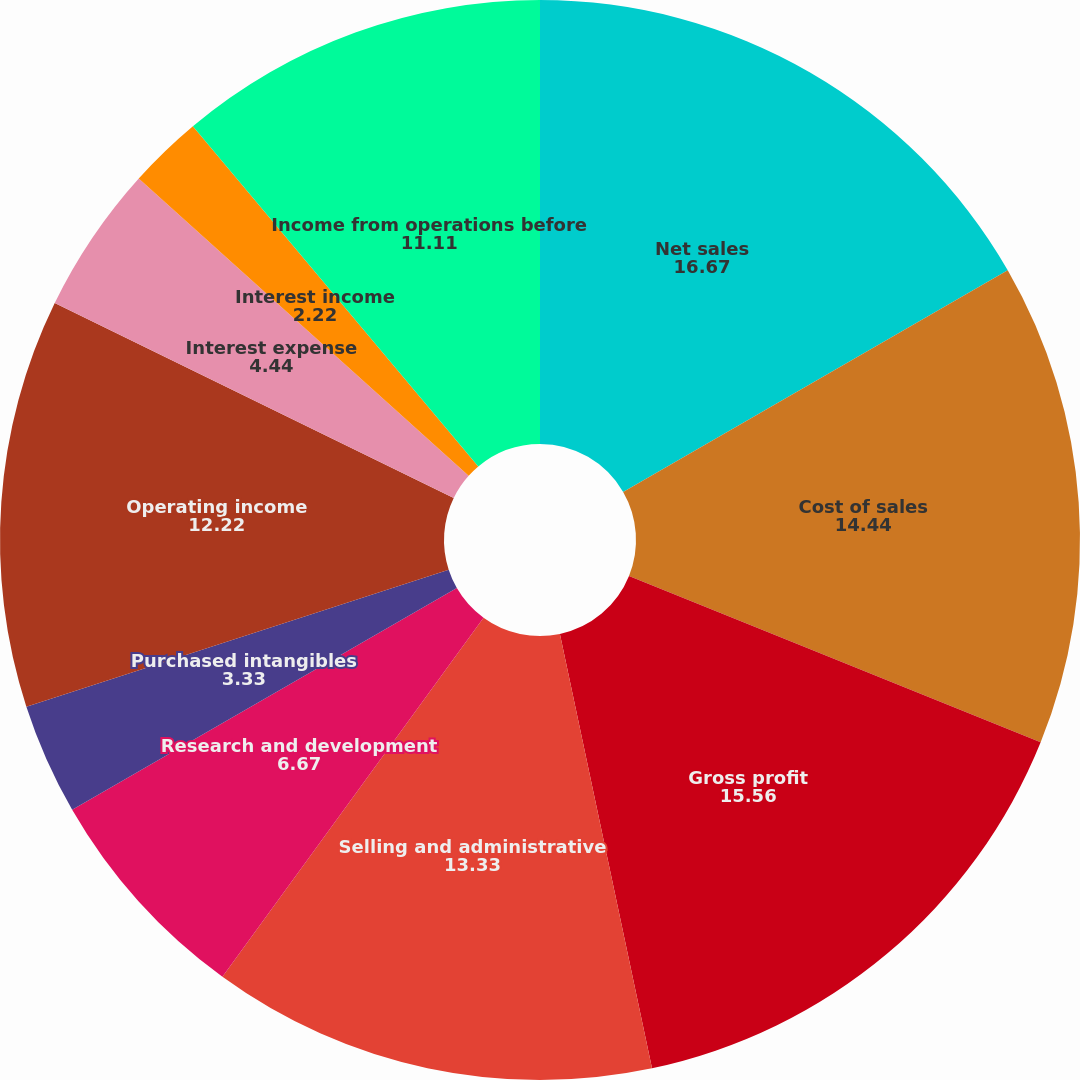<chart> <loc_0><loc_0><loc_500><loc_500><pie_chart><fcel>Net sales<fcel>Cost of sales<fcel>Gross profit<fcel>Selling and administrative<fcel>Research and development<fcel>Purchased intangibles<fcel>Operating income<fcel>Interest expense<fcel>Interest income<fcel>Income from operations before<nl><fcel>16.67%<fcel>14.44%<fcel>15.56%<fcel>13.33%<fcel>6.67%<fcel>3.33%<fcel>12.22%<fcel>4.44%<fcel>2.22%<fcel>11.11%<nl></chart> 